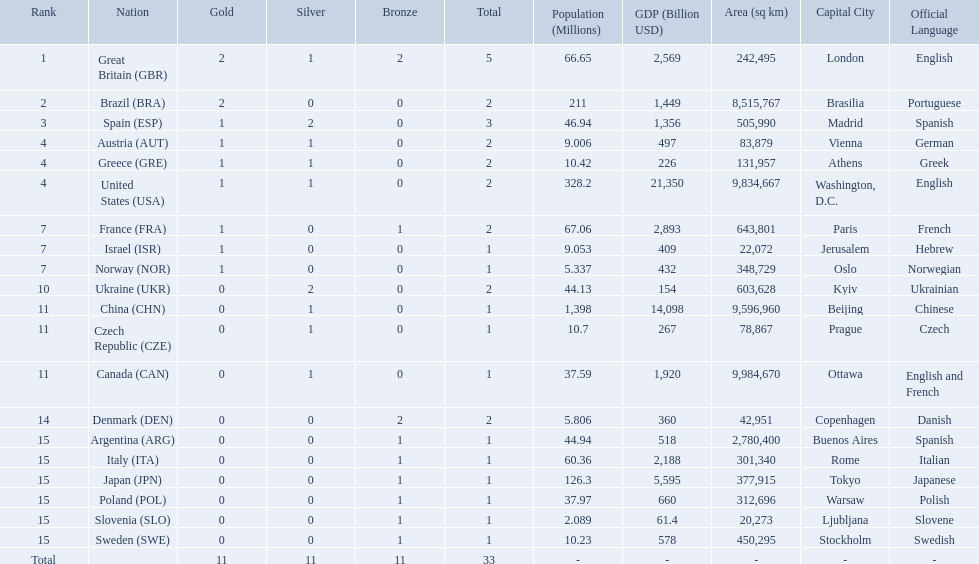Can you give me this table as a dict? {'header': ['Rank', 'Nation', 'Gold', 'Silver', 'Bronze', 'Total', 'Population (Millions)', 'GDP (Billion USD)', 'Area (sq km)', 'Capital City', 'Official Language'], 'rows': [['1', 'Great Britain\xa0(GBR)', '2', '1', '2', '5', '66.65', '2,569', '242,495', 'London', 'English'], ['2', 'Brazil\xa0(BRA)', '2', '0', '0', '2', '211', '1,449', '8,515,767', 'Brasilia', 'Portuguese'], ['3', 'Spain\xa0(ESP)', '1', '2', '0', '3', '46.94', '1,356', '505,990', 'Madrid', 'Spanish'], ['4', 'Austria\xa0(AUT)', '1', '1', '0', '2', '9.006', '497', '83,879', 'Vienna', 'German'], ['4', 'Greece\xa0(GRE)', '1', '1', '0', '2', '10.42', '226', '131,957', 'Athens', 'Greek'], ['4', 'United States\xa0(USA)', '1', '1', '0', '2', '328.2', '21,350', '9,834,667', 'Washington, D.C.', 'English'], ['7', 'France\xa0(FRA)', '1', '0', '1', '2', '67.06', '2,893', '643,801', 'Paris', 'French'], ['7', 'Israel\xa0(ISR)', '1', '0', '0', '1', '9.053', '409', '22,072', 'Jerusalem', 'Hebrew'], ['7', 'Norway\xa0(NOR)', '1', '0', '0', '1', '5.337', '432', '348,729', 'Oslo', 'Norwegian'], ['10', 'Ukraine\xa0(UKR)', '0', '2', '0', '2', '44.13', '154', '603,628', 'Kyiv', 'Ukrainian'], ['11', 'China\xa0(CHN)', '0', '1', '0', '1', '1,398', '14,098', '9,596,960', 'Beijing', 'Chinese'], ['11', 'Czech Republic\xa0(CZE)', '0', '1', '0', '1', '10.7', '267', '78,867', 'Prague', 'Czech'], ['11', 'Canada\xa0(CAN)', '0', '1', '0', '1', '37.59', '1,920', '9,984,670', 'Ottawa', 'English and French'], ['14', 'Denmark\xa0(DEN)', '0', '0', '2', '2', '5.806', '360', '42,951', 'Copenhagen', 'Danish'], ['15', 'Argentina\xa0(ARG)', '0', '0', '1', '1', '44.94', '518', '2,780,400', 'Buenos Aires', 'Spanish'], ['15', 'Italy\xa0(ITA)', '0', '0', '1', '1', '60.36', '2,188', '301,340', 'Rome', 'Italian'], ['15', 'Japan\xa0(JPN)', '0', '0', '1', '1', '126.3', '5,595', '377,915', 'Tokyo', 'Japanese'], ['15', 'Poland\xa0(POL)', '0', '0', '1', '1', '37.97', '660', '312,696', 'Warsaw', 'Polish'], ['15', 'Slovenia\xa0(SLO)', '0', '0', '1', '1', '2.089', '61.4', '20,273', 'Ljubljana', 'Slovene'], ['15', 'Sweden\xa0(SWE)', '0', '0', '1', '1', '10.23', '578', '450,295', 'Stockholm', 'Swedish'], ['Total', '', '11', '11', '11', '33', '-', '-', '-', '-', '-']]} How many medals did each country receive? 5, 2, 3, 2, 2, 2, 2, 1, 1, 2, 1, 1, 1, 2, 1, 1, 1, 1, 1, 1. Which country received 3 medals? Spain (ESP). What are all of the countries? Great Britain (GBR), Brazil (BRA), Spain (ESP), Austria (AUT), Greece (GRE), United States (USA), France (FRA), Israel (ISR), Norway (NOR), Ukraine (UKR), China (CHN), Czech Republic (CZE), Canada (CAN), Denmark (DEN), Argentina (ARG), Italy (ITA), Japan (JPN), Poland (POL), Slovenia (SLO), Sweden (SWE). Which ones earned a medal? Great Britain (GBR), Brazil (BRA), Spain (ESP), Austria (AUT), Greece (GRE), United States (USA), France (FRA), Israel (ISR), Norway (NOR), Ukraine (UKR), China (CHN), Czech Republic (CZE), Canada (CAN), Denmark (DEN), Argentina (ARG), Italy (ITA), Japan (JPN), Poland (POL), Slovenia (SLO), Sweden (SWE). Which countries earned at least 3 medals? Great Britain (GBR), Spain (ESP). Which country earned 3 medals? Spain (ESP). Which nation received 2 silver medals? Spain (ESP), Ukraine (UKR). Of those, which nation also had 2 total medals? Spain (ESP). How many medals did spain gain 3. Only country that got more medals? Spain (ESP). 